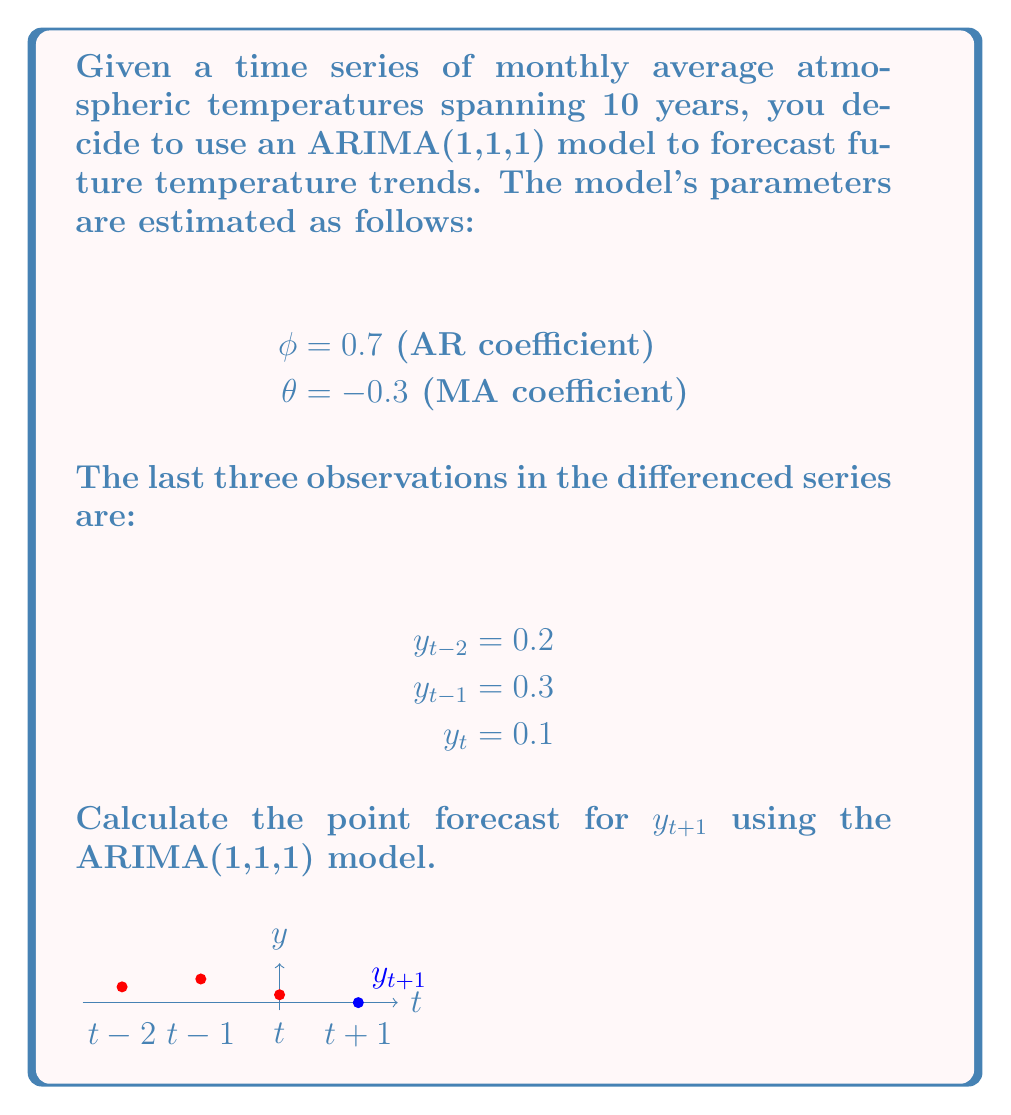Give your solution to this math problem. To calculate the point forecast for $y_{t+1}$ using the ARIMA(1,1,1) model, we need to follow these steps:

1) Recall the general form of an ARIMA(1,1,1) model:

   $$(1 - \phi B)(1 - B)y_t = (1 + \theta B)\epsilon_t$$

   where $B$ is the backshift operator.

2) Expanding this equation:

   $$y_t - y_{t-1} - \phi(y_{t-1} - y_{t-2}) = \epsilon_t + \theta\epsilon_{t-1}$$

3) Rearranging to isolate $y_t$:

   $$y_t = y_{t-1} + \phi(y_{t-1} - y_{t-2}) + \epsilon_t + \theta\epsilon_{t-1}$$

4) For forecasting, we set future error terms to their expected value of 0:

   $$\hat{y}_{t+1} = y_t + \phi(y_t - y_{t-1}) + \theta\epsilon_t$$

5) We don't know $\epsilon_t$ directly, but we can estimate it as the difference between the observed value and its one-step-ahead forecast:

   $$\epsilon_t = y_t - (y_{t-1} + \phi(y_{t-1} - y_{t-2}))$$

6) Substituting the given values:

   $$\epsilon_t = 0.1 - (0.3 + 0.7(0.3 - 0.2)) = 0.1 - 0.3 - 0.07 = -0.27$$

7) Now we can calculate $\hat{y}_{t+1}$:

   $$\hat{y}_{t+1} = 0.1 + 0.7(0.1 - 0.3) + (-0.3)(-0.27)$$
   $$= 0.1 - 0.14 + 0.081$$
   $$= 0.041$$

Therefore, the point forecast for $y_{t+1}$ is 0.041.
Answer: 0.041 